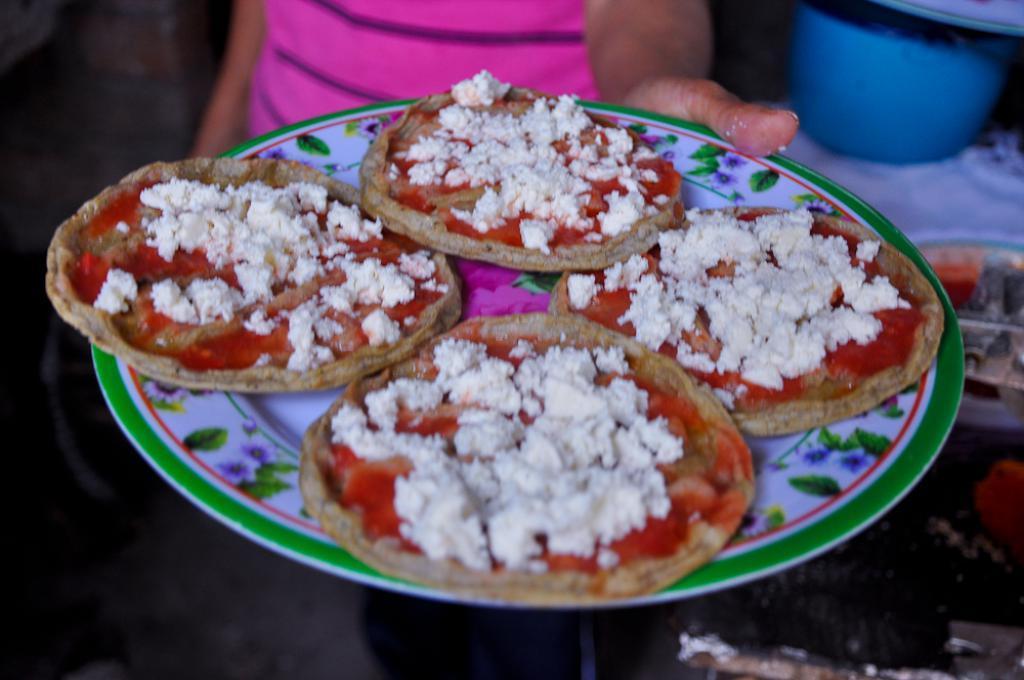Please provide a concise description of this image. In this image, we can see a person who´s face is not visible holding a plate contains some food. There is an object in the top right of the image. 